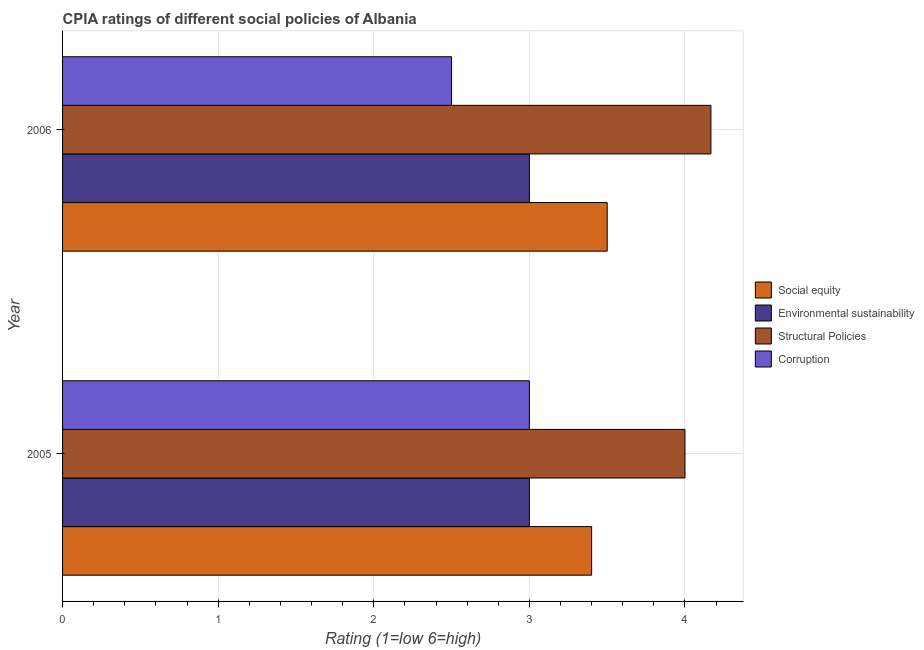How many different coloured bars are there?
Give a very brief answer. 4. How many groups of bars are there?
Provide a short and direct response. 2. Are the number of bars per tick equal to the number of legend labels?
Your response must be concise. Yes. Are the number of bars on each tick of the Y-axis equal?
Make the answer very short. Yes. What is the label of the 1st group of bars from the top?
Offer a terse response. 2006. In how many cases, is the number of bars for a given year not equal to the number of legend labels?
Your answer should be compact. 0. Across all years, what is the minimum cpia rating of social equity?
Keep it short and to the point. 3.4. In which year was the cpia rating of environmental sustainability maximum?
Offer a terse response. 2005. In which year was the cpia rating of social equity minimum?
Give a very brief answer. 2005. What is the total cpia rating of structural policies in the graph?
Provide a short and direct response. 8.17. What is the difference between the cpia rating of environmental sustainability in 2005 and that in 2006?
Keep it short and to the point. 0. What is the difference between the cpia rating of structural policies in 2006 and the cpia rating of social equity in 2005?
Provide a succinct answer. 0.77. What is the average cpia rating of structural policies per year?
Ensure brevity in your answer.  4.08. In how many years, is the cpia rating of corruption greater than 1.2 ?
Ensure brevity in your answer.  2. Is the cpia rating of corruption in 2005 less than that in 2006?
Provide a succinct answer. No. In how many years, is the cpia rating of structural policies greater than the average cpia rating of structural policies taken over all years?
Your response must be concise. 1. What does the 4th bar from the top in 2005 represents?
Your answer should be very brief. Social equity. What does the 3rd bar from the bottom in 2006 represents?
Your answer should be very brief. Structural Policies. Is it the case that in every year, the sum of the cpia rating of social equity and cpia rating of environmental sustainability is greater than the cpia rating of structural policies?
Offer a terse response. Yes. How many years are there in the graph?
Your answer should be compact. 2. What is the difference between two consecutive major ticks on the X-axis?
Ensure brevity in your answer.  1. Are the values on the major ticks of X-axis written in scientific E-notation?
Give a very brief answer. No. What is the title of the graph?
Give a very brief answer. CPIA ratings of different social policies of Albania. Does "Terrestrial protected areas" appear as one of the legend labels in the graph?
Provide a succinct answer. No. What is the label or title of the Y-axis?
Your answer should be very brief. Year. What is the Rating (1=low 6=high) in Environmental sustainability in 2005?
Offer a very short reply. 3. What is the Rating (1=low 6=high) of Structural Policies in 2005?
Your response must be concise. 4. What is the Rating (1=low 6=high) in Corruption in 2005?
Provide a short and direct response. 3. What is the Rating (1=low 6=high) in Social equity in 2006?
Ensure brevity in your answer.  3.5. What is the Rating (1=low 6=high) of Environmental sustainability in 2006?
Provide a succinct answer. 3. What is the Rating (1=low 6=high) of Structural Policies in 2006?
Your answer should be compact. 4.17. Across all years, what is the maximum Rating (1=low 6=high) of Social equity?
Your answer should be compact. 3.5. Across all years, what is the maximum Rating (1=low 6=high) of Structural Policies?
Give a very brief answer. 4.17. Across all years, what is the maximum Rating (1=low 6=high) in Corruption?
Offer a very short reply. 3. Across all years, what is the minimum Rating (1=low 6=high) in Social equity?
Offer a terse response. 3.4. Across all years, what is the minimum Rating (1=low 6=high) in Environmental sustainability?
Keep it short and to the point. 3. Across all years, what is the minimum Rating (1=low 6=high) in Structural Policies?
Your answer should be very brief. 4. Across all years, what is the minimum Rating (1=low 6=high) of Corruption?
Ensure brevity in your answer.  2.5. What is the total Rating (1=low 6=high) in Social equity in the graph?
Provide a succinct answer. 6.9. What is the total Rating (1=low 6=high) of Environmental sustainability in the graph?
Offer a terse response. 6. What is the total Rating (1=low 6=high) in Structural Policies in the graph?
Your answer should be very brief. 8.17. What is the total Rating (1=low 6=high) in Corruption in the graph?
Your answer should be very brief. 5.5. What is the difference between the Rating (1=low 6=high) in Social equity in 2005 and that in 2006?
Provide a short and direct response. -0.1. What is the difference between the Rating (1=low 6=high) of Environmental sustainability in 2005 and that in 2006?
Your answer should be compact. 0. What is the difference between the Rating (1=low 6=high) of Social equity in 2005 and the Rating (1=low 6=high) of Environmental sustainability in 2006?
Give a very brief answer. 0.4. What is the difference between the Rating (1=low 6=high) of Social equity in 2005 and the Rating (1=low 6=high) of Structural Policies in 2006?
Offer a terse response. -0.77. What is the difference between the Rating (1=low 6=high) in Environmental sustainability in 2005 and the Rating (1=low 6=high) in Structural Policies in 2006?
Give a very brief answer. -1.17. What is the difference between the Rating (1=low 6=high) of Environmental sustainability in 2005 and the Rating (1=low 6=high) of Corruption in 2006?
Ensure brevity in your answer.  0.5. What is the average Rating (1=low 6=high) of Social equity per year?
Offer a terse response. 3.45. What is the average Rating (1=low 6=high) in Environmental sustainability per year?
Offer a very short reply. 3. What is the average Rating (1=low 6=high) of Structural Policies per year?
Give a very brief answer. 4.08. What is the average Rating (1=low 6=high) in Corruption per year?
Keep it short and to the point. 2.75. In the year 2005, what is the difference between the Rating (1=low 6=high) of Social equity and Rating (1=low 6=high) of Environmental sustainability?
Give a very brief answer. 0.4. In the year 2005, what is the difference between the Rating (1=low 6=high) of Social equity and Rating (1=low 6=high) of Corruption?
Your response must be concise. 0.4. In the year 2005, what is the difference between the Rating (1=low 6=high) of Structural Policies and Rating (1=low 6=high) of Corruption?
Your answer should be very brief. 1. In the year 2006, what is the difference between the Rating (1=low 6=high) of Social equity and Rating (1=low 6=high) of Structural Policies?
Offer a terse response. -0.67. In the year 2006, what is the difference between the Rating (1=low 6=high) in Social equity and Rating (1=low 6=high) in Corruption?
Provide a succinct answer. 1. In the year 2006, what is the difference between the Rating (1=low 6=high) in Environmental sustainability and Rating (1=low 6=high) in Structural Policies?
Provide a short and direct response. -1.17. What is the ratio of the Rating (1=low 6=high) in Social equity in 2005 to that in 2006?
Provide a succinct answer. 0.97. What is the ratio of the Rating (1=low 6=high) of Structural Policies in 2005 to that in 2006?
Your answer should be very brief. 0.96. What is the difference between the highest and the second highest Rating (1=low 6=high) in Environmental sustainability?
Offer a terse response. 0. What is the difference between the highest and the second highest Rating (1=low 6=high) of Corruption?
Your response must be concise. 0.5. What is the difference between the highest and the lowest Rating (1=low 6=high) in Social equity?
Make the answer very short. 0.1. What is the difference between the highest and the lowest Rating (1=low 6=high) in Environmental sustainability?
Give a very brief answer. 0. What is the difference between the highest and the lowest Rating (1=low 6=high) in Corruption?
Your answer should be very brief. 0.5. 